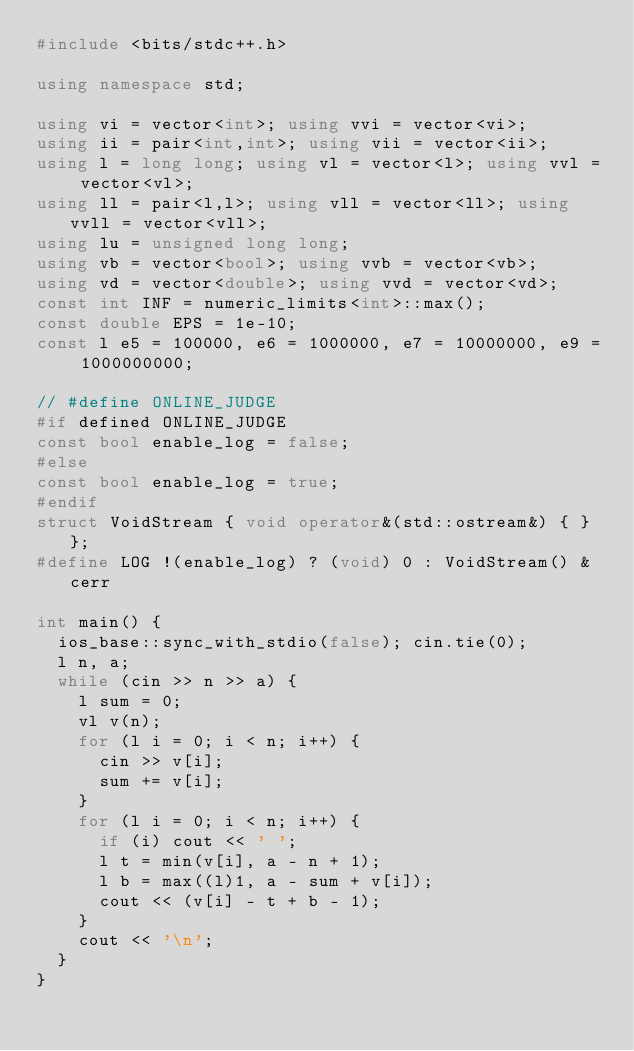Convert code to text. <code><loc_0><loc_0><loc_500><loc_500><_C++_>#include <bits/stdc++.h>

using namespace std;

using vi = vector<int>; using vvi = vector<vi>;
using ii = pair<int,int>; using vii = vector<ii>;
using l = long long; using vl = vector<l>; using vvl = vector<vl>;
using ll = pair<l,l>; using vll = vector<ll>; using vvll = vector<vll>;
using lu = unsigned long long;
using vb = vector<bool>; using vvb = vector<vb>;
using vd = vector<double>; using vvd = vector<vd>;
const int INF = numeric_limits<int>::max();
const double EPS = 1e-10;
const l e5 = 100000, e6 = 1000000, e7 = 10000000, e9 = 1000000000;

// #define ONLINE_JUDGE
#if defined ONLINE_JUDGE
const bool enable_log = false;
#else
const bool enable_log = true;
#endif
struct VoidStream { void operator&(std::ostream&) { } };
#define LOG !(enable_log) ? (void) 0 : VoidStream() & cerr

int main() {
  ios_base::sync_with_stdio(false); cin.tie(0);
  l n, a;
  while (cin >> n >> a) {
    l sum = 0;
    vl v(n);
    for (l i = 0; i < n; i++) {
      cin >> v[i];
      sum += v[i];
    }
    for (l i = 0; i < n; i++) {
      if (i) cout << ' ';
      l t = min(v[i], a - n + 1);
      l b = max((l)1, a - sum + v[i]);
      cout << (v[i] - t + b - 1);
    }
    cout << '\n';
  }
}
</code> 